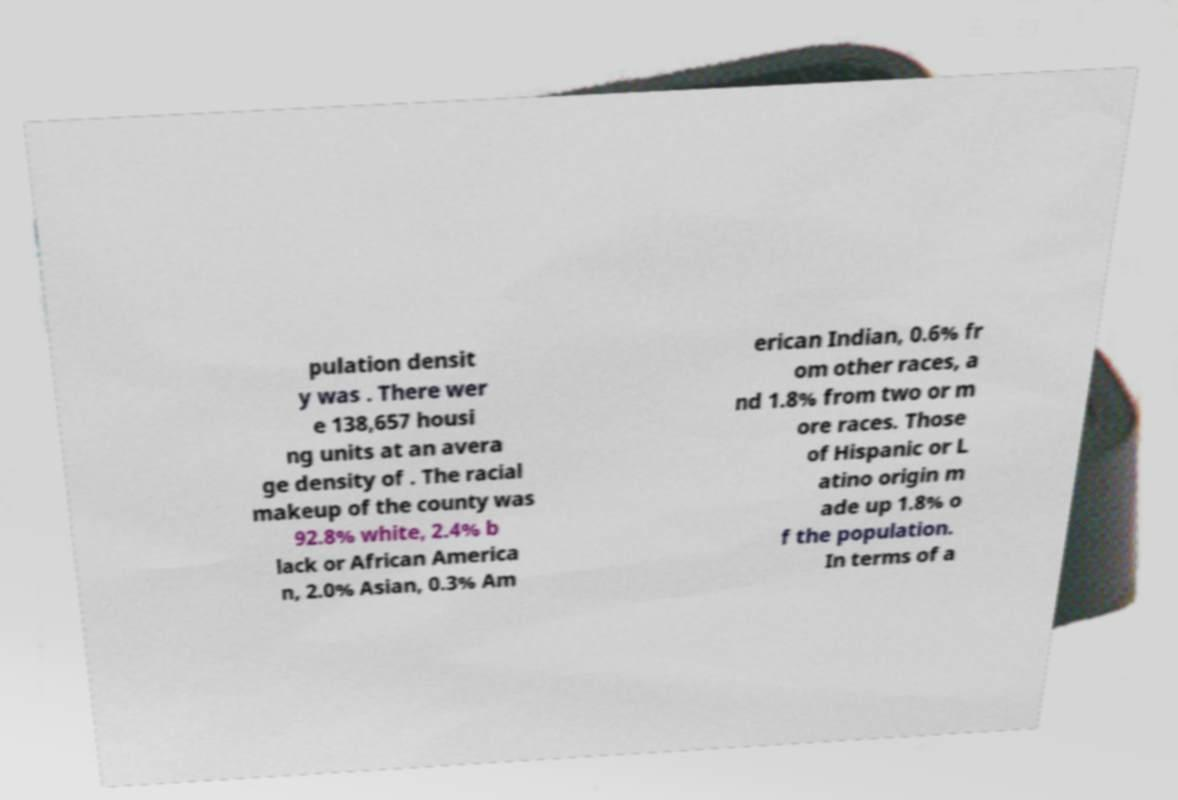For documentation purposes, I need the text within this image transcribed. Could you provide that? pulation densit y was . There wer e 138,657 housi ng units at an avera ge density of . The racial makeup of the county was 92.8% white, 2.4% b lack or African America n, 2.0% Asian, 0.3% Am erican Indian, 0.6% fr om other races, a nd 1.8% from two or m ore races. Those of Hispanic or L atino origin m ade up 1.8% o f the population. In terms of a 